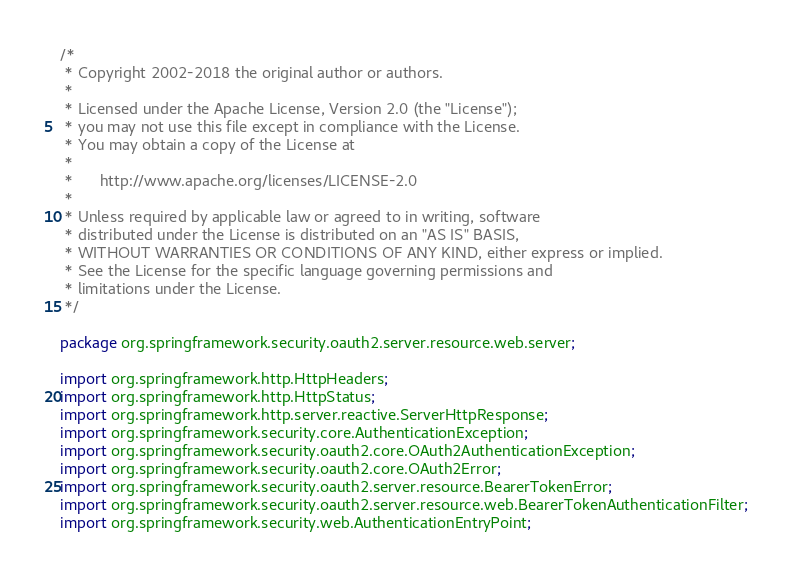<code> <loc_0><loc_0><loc_500><loc_500><_Java_>/*
 * Copyright 2002-2018 the original author or authors.
 *
 * Licensed under the Apache License, Version 2.0 (the "License");
 * you may not use this file except in compliance with the License.
 * You may obtain a copy of the License at
 *
 *      http://www.apache.org/licenses/LICENSE-2.0
 *
 * Unless required by applicable law or agreed to in writing, software
 * distributed under the License is distributed on an "AS IS" BASIS,
 * WITHOUT WARRANTIES OR CONDITIONS OF ANY KIND, either express or implied.
 * See the License for the specific language governing permissions and
 * limitations under the License.
 */

package org.springframework.security.oauth2.server.resource.web.server;

import org.springframework.http.HttpHeaders;
import org.springframework.http.HttpStatus;
import org.springframework.http.server.reactive.ServerHttpResponse;
import org.springframework.security.core.AuthenticationException;
import org.springframework.security.oauth2.core.OAuth2AuthenticationException;
import org.springframework.security.oauth2.core.OAuth2Error;
import org.springframework.security.oauth2.server.resource.BearerTokenError;
import org.springframework.security.oauth2.server.resource.web.BearerTokenAuthenticationFilter;
import org.springframework.security.web.AuthenticationEntryPoint;</code> 